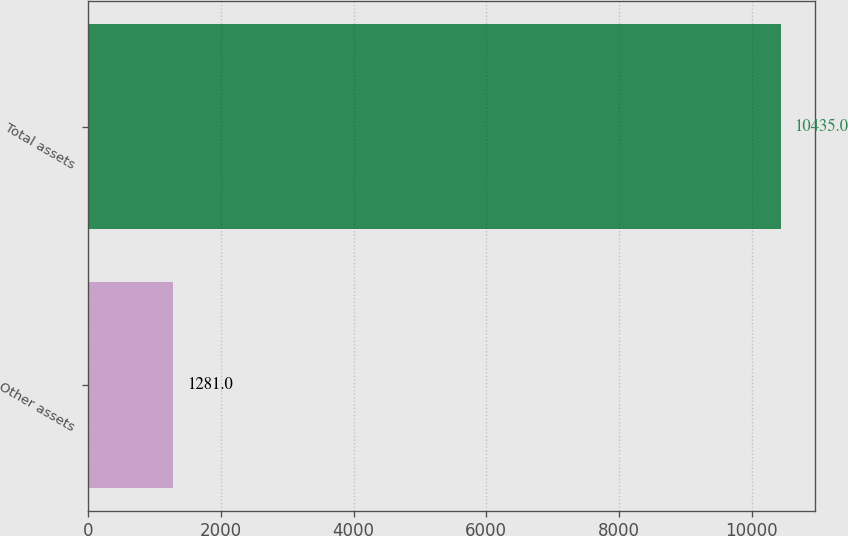Convert chart to OTSL. <chart><loc_0><loc_0><loc_500><loc_500><bar_chart><fcel>Other assets<fcel>Total assets<nl><fcel>1281<fcel>10435<nl></chart> 